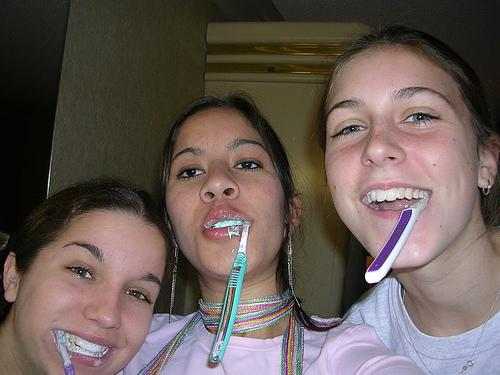What color is the toothbrush in the mouth of the woman in the center? Please explain your reasoning. turquoise. It's a lighter blue green color 